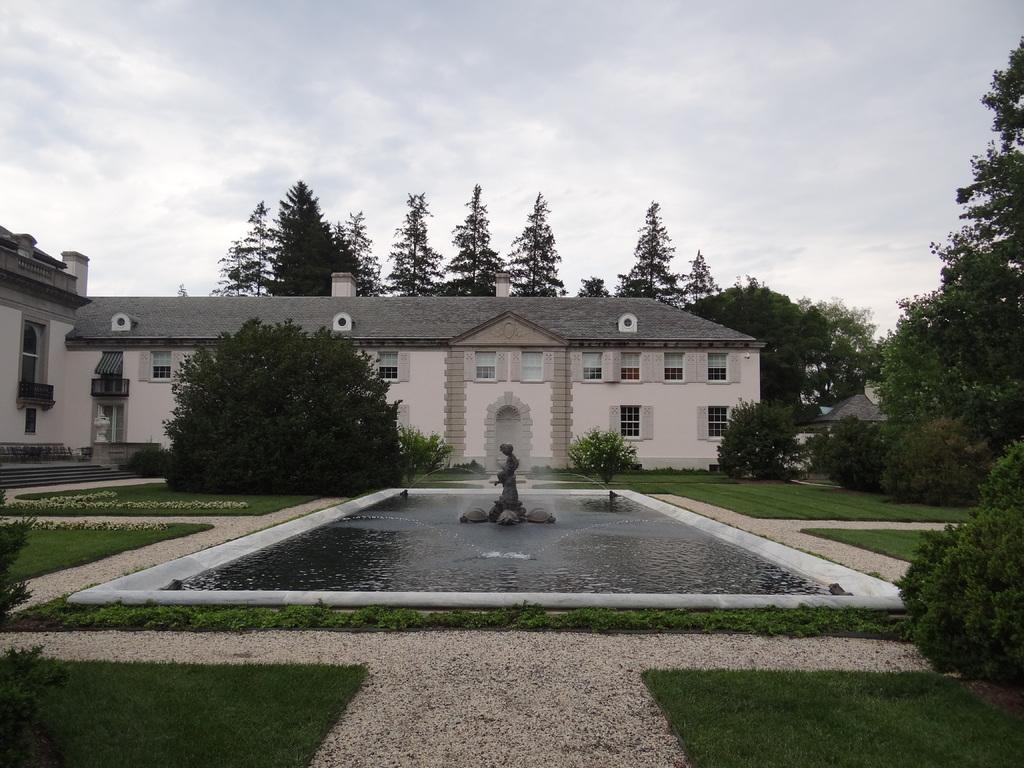Can you describe this image briefly? This is the picture of a building. In the foreground there is statue and there is a fountain. At the back there are buildings and trees. At the top there is sky and there are clouds. At the bottom there is grass and water. 